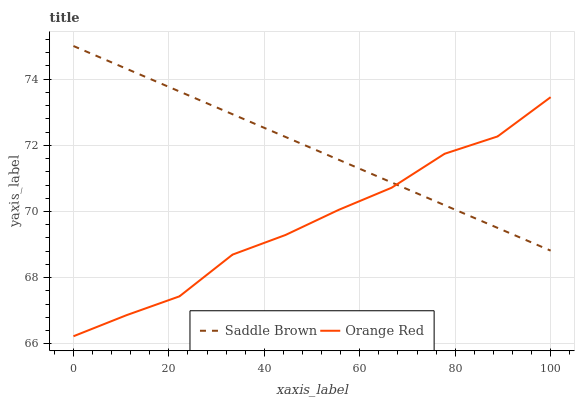Does Orange Red have the maximum area under the curve?
Answer yes or no. No. Is Orange Red the smoothest?
Answer yes or no. No. Does Orange Red have the highest value?
Answer yes or no. No. 